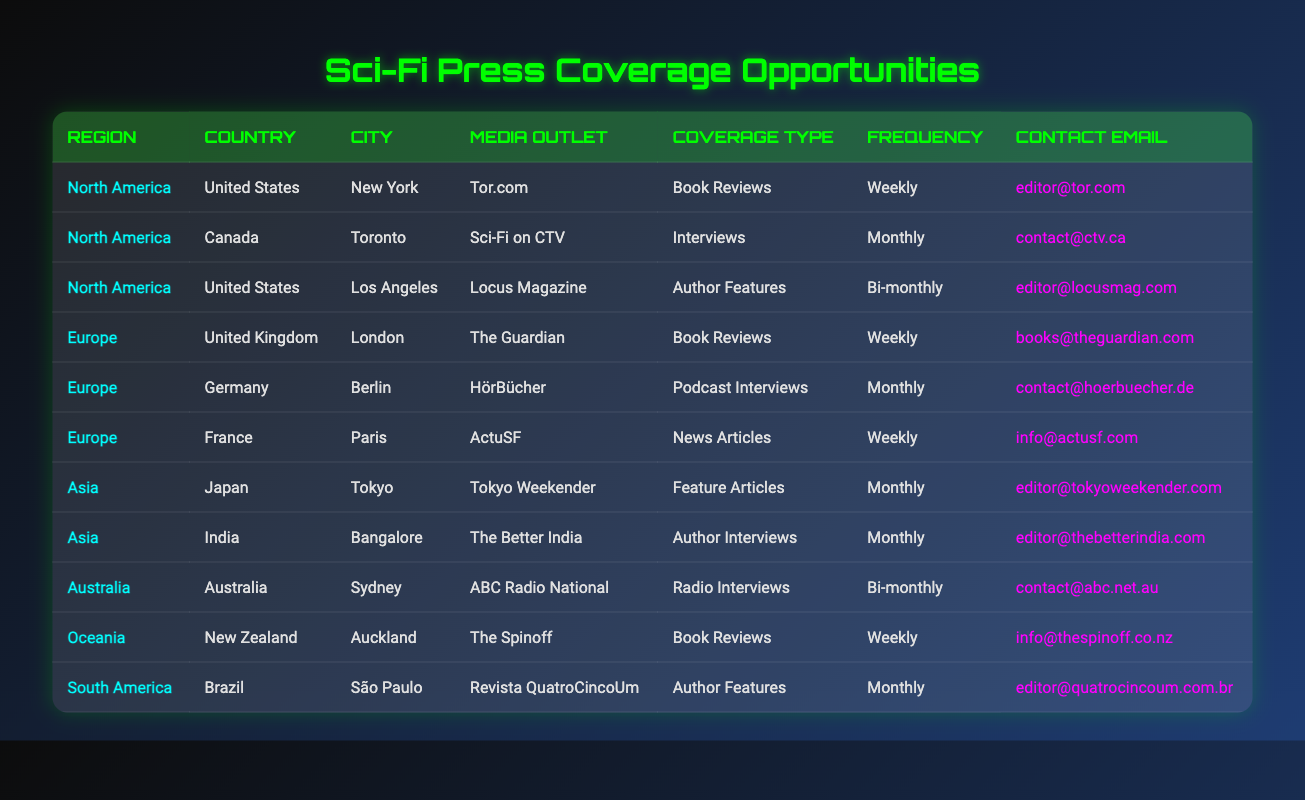What is the contact email for Tor.com? The table lists the contact email for Tor.com under the media outlet in New York, United States, which is editor@tor.com.
Answer: editor@tor.com How many press coverage opportunities are available in Europe? By counting the rows in the table that have "Europe" in the region, we see there are three entries: The Guardian, HörBücher, and ActuSF.
Answer: 3 Does Sci-Fi on CTV offer book reviews? The table indicates that Sci-Fi on CTV provides interviews, not book reviews, so the answer is no.
Answer: No Which city has the most frequent press coverage opportunities? Looking through the frequencies listed in the table, both New York and London have weekly coverage, making them the cities with the most frequent opportunities.
Answer: New York and London If we consider only North America, what types of coverage are available? In the North America region, the table shows three types of coverage: Book Reviews from Tor.com, Interviews from Sci-Fi on CTV, and Author Features from Locus Magazine.
Answer: Book Reviews, Interviews, Author Features How many authors can expect interviews monthly in Asia based on the table? The table shows that both Tokyo Weekender and The Better India provide opportunities for monthly interviews, so there are two opportunities for authors in Asia.
Answer: 2 What is the total number of press opportunities listed in the table? There are 10 media outlets listed in the table; each media outlet represents a press opportunity, so the total is 10.
Answer: 10 Which coverage type is provided the least often among the media outlets listed? By examining the frequency column, the least often provided coverage type is "Bi-monthly," offered by Locus Magazine and ABC Radio National.
Answer: Bi-monthly Is there any coverage for authors in South America? Yes, the table shows that Revista QuatroCincoUm in Brazil offers Author Features as coverage for authors in South America.
Answer: Yes 